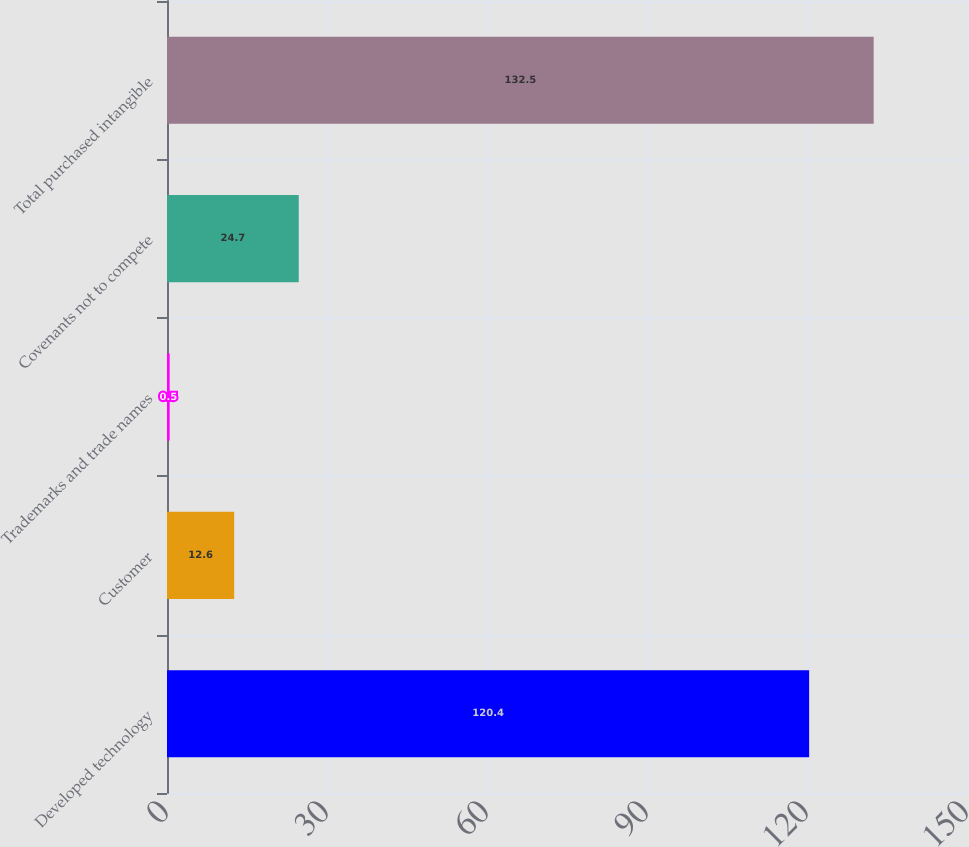<chart> <loc_0><loc_0><loc_500><loc_500><bar_chart><fcel>Developed technology<fcel>Customer<fcel>Trademarks and trade names<fcel>Covenants not to compete<fcel>Total purchased intangible<nl><fcel>120.4<fcel>12.6<fcel>0.5<fcel>24.7<fcel>132.5<nl></chart> 